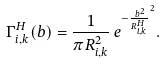<formula> <loc_0><loc_0><loc_500><loc_500>\Gamma _ { i , k } ^ { H } ( b ) = \frac { 1 } { \pi R _ { i , k } ^ { 2 } } \, e ^ { - \frac { \, b ^ { 2 } } { R _ { i , k } ^ { H } } ^ { 2 } } .</formula> 